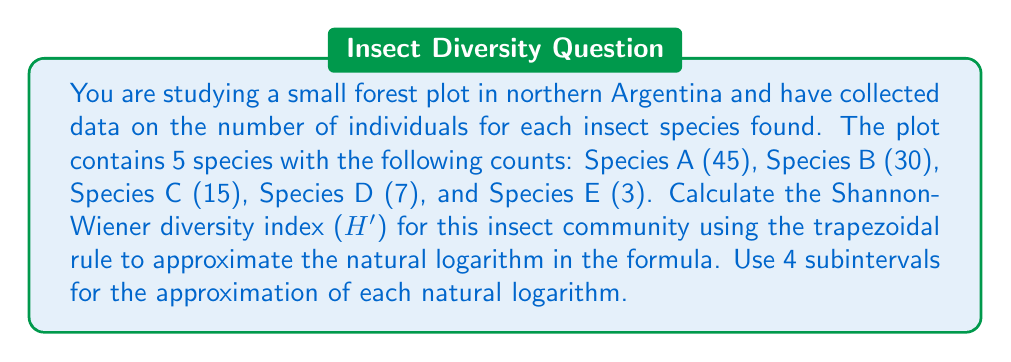Give your solution to this math problem. To calculate the Shannon-Wiener diversity index (H'), we use the formula:

$$H' = -\sum_{i=1}^S p_i \ln(p_i)$$

Where $S$ is the number of species, and $p_i$ is the proportion of individuals belonging to species $i$.

Step 1: Calculate the total number of individuals and the proportion for each species.
Total individuals: 45 + 30 + 15 + 7 + 3 = 100

$p_1 = 45/100 = 0.45$
$p_2 = 30/100 = 0.30$
$p_3 = 15/100 = 0.15$
$p_4 = 7/100 = 0.07$
$p_5 = 3/100 = 0.03$

Step 2: Use the trapezoidal rule to approximate $\ln(p_i)$ for each species.
The trapezoidal rule for $\ln(x)$ from 1 to $x$ with 4 subintervals is:

$$\ln(x) \approx \frac{x-1}{4}\left[\frac{1}{1} + \frac{2}{1+\frac{x-1}{4}} + \frac{2}{1+\frac{2(x-1)}{4}} + \frac{2}{1+\frac{3(x-1)}{4}} + \frac{1}{x}\right]$$

For $p_1 = 0.45$:
$$\ln(0.45) \approx \frac{0.45-1}{4}\left[1 + \frac{2}{1+\frac{0.45-1}{4}} + \frac{2}{1+\frac{2(0.45-1)}{4}} + \frac{2}{1+\frac{3(0.45-1)}{4}} + \frac{1}{0.45}\right] \approx -0.7985$$

Similarly, we calculate for the other species:
$\ln(0.30) \approx -1.2040$
$\ln(0.15) \approx -1.8971$
$\ln(0.07) \approx -2.6593$
$\ln(0.03) \approx -3.5066$

Step 3: Calculate $H'$ using the approximated values:

$$\begin{align}
H' &= -[0.45 \cdot (-0.7985) + 0.30 \cdot (-1.2040) + 0.15 \cdot (-1.8971) + 0.07 \cdot (-2.6593) + 0.03 \cdot (-3.5066)] \\
&= -([-0.3593] + [-0.3612] + [-0.2846] + [-0.1862] + [-0.1052]) \\
&= -(-1.2965) \\
&= 1.2965
\end{align}$$
Answer: $H' \approx 1.2965$ 